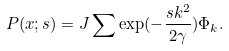Convert formula to latex. <formula><loc_0><loc_0><loc_500><loc_500>P ( x ; s ) = J \sum \exp ( - \frac { s k ^ { 2 } } { 2 \gamma } ) \Phi _ { k } .</formula> 